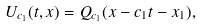<formula> <loc_0><loc_0><loc_500><loc_500>U _ { c _ { 1 } } ( t , x ) = Q _ { c _ { 1 } } ( x - c _ { 1 } t - x _ { 1 } ) ,</formula> 